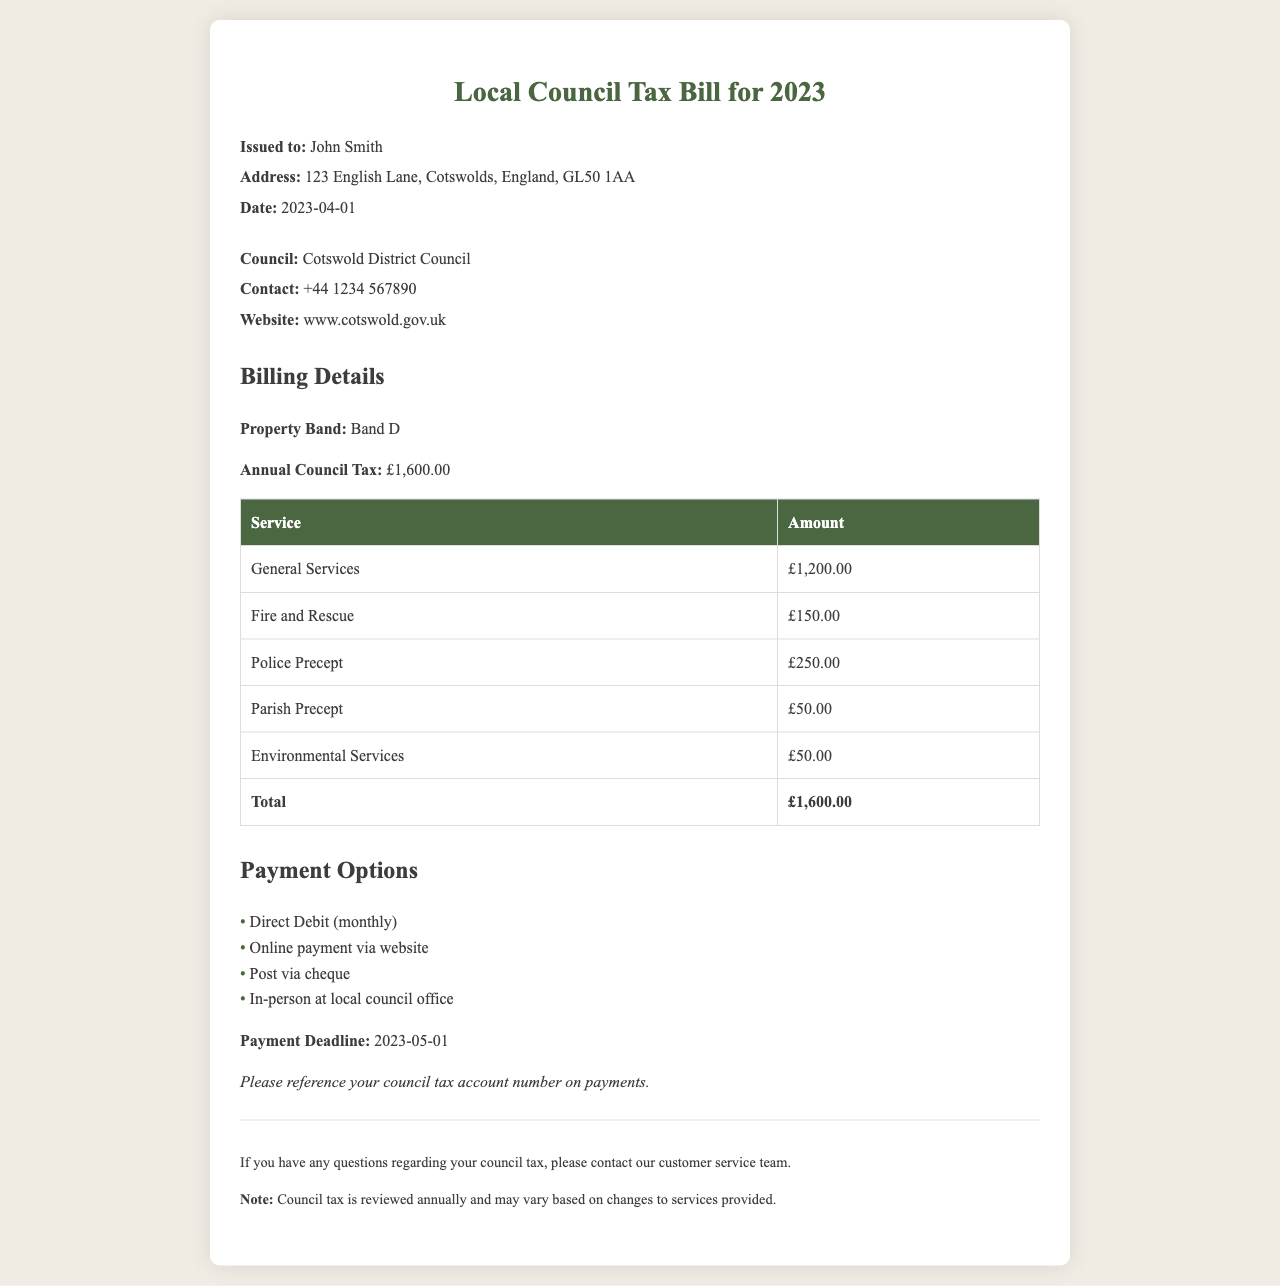what is the total annual council tax? The total annual council tax is explicitly listed as £1,600.00 in the document.
Answer: £1,600.00 what is the property band? The property band is specified in the billing details section and is listed as Band D.
Answer: Band D who is the issued person? The issued person is mentioned in the header section, indicating the name as John Smith.
Answer: John Smith when is the payment deadline? The payment deadline is stated in the payment options section as 2023-05-01.
Answer: 2023-05-01 how much is allocated for Police Precept? The allocated amount for Police Precept is detailed in the billing table as £250.00.
Answer: £250.00 which council is issuing the tax bill? The council issuing the tax bill is mentioned, and it is Cotswold District Council.
Answer: Cotswold District Council what are two payment options available? The document lists several payment options, including Direct Debit and Online payment via website.
Answer: Direct Debit, Online payment how many services are listed in the billing details? The billing details section contains a table with five different services detailed.
Answer: five what is the contact number for the council? The contact number for the council is provided as +44 1234 567890.
Answer: +44 1234 567890 what is the total amount for General Services? The total amount allocated for General Services is listed in the billing details section as £1,200.00.
Answer: £1,200.00 